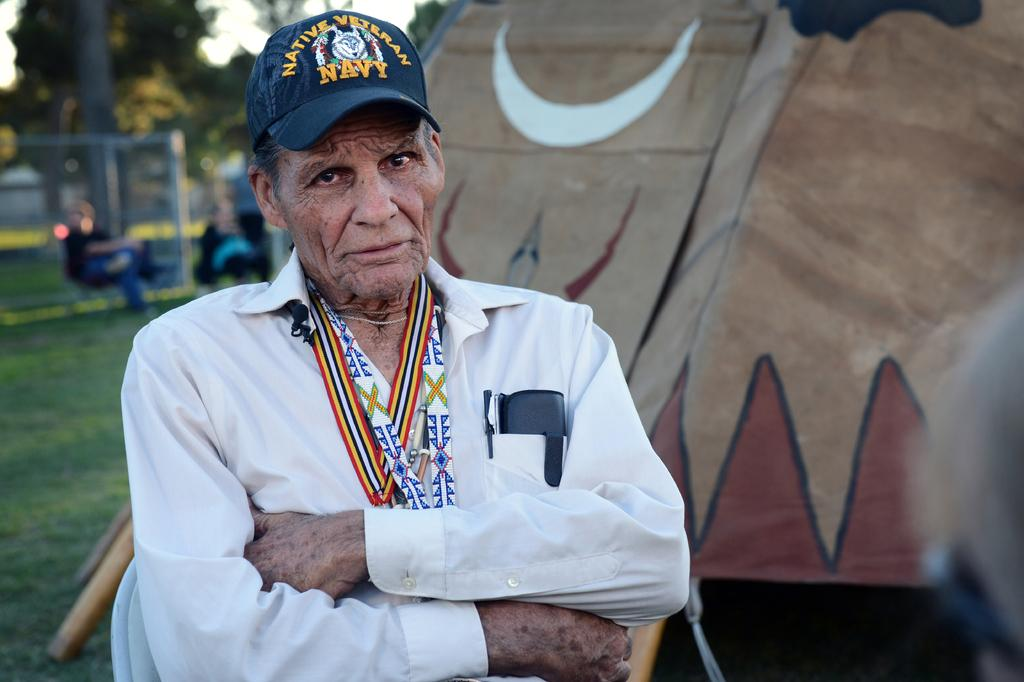<image>
Write a terse but informative summary of the picture. a man looking at the camera outside with a Navy hat 